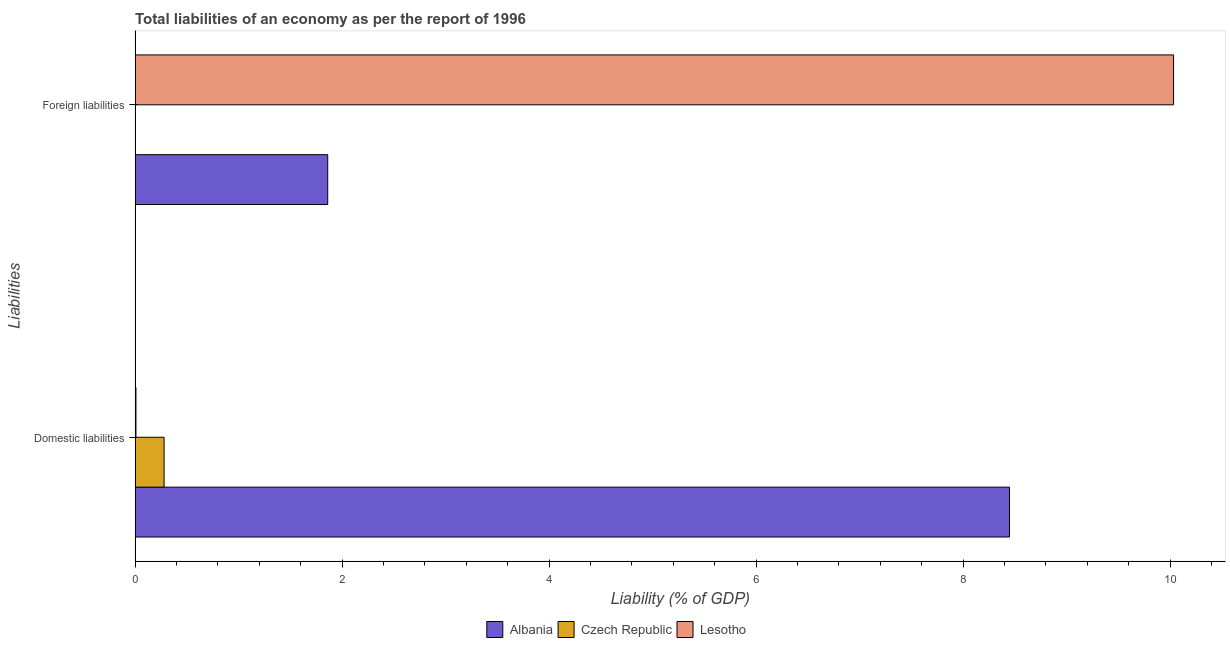How many different coloured bars are there?
Offer a terse response. 3. Are the number of bars on each tick of the Y-axis equal?
Make the answer very short. No. What is the label of the 1st group of bars from the top?
Provide a short and direct response. Foreign liabilities. What is the incurrence of domestic liabilities in Albania?
Your answer should be compact. 8.45. Across all countries, what is the maximum incurrence of domestic liabilities?
Your answer should be compact. 8.45. Across all countries, what is the minimum incurrence of domestic liabilities?
Offer a terse response. 0.01. In which country was the incurrence of domestic liabilities maximum?
Your response must be concise. Albania. What is the total incurrence of foreign liabilities in the graph?
Your answer should be compact. 11.9. What is the difference between the incurrence of domestic liabilities in Albania and that in Czech Republic?
Make the answer very short. 8.17. What is the difference between the incurrence of foreign liabilities in Czech Republic and the incurrence of domestic liabilities in Albania?
Give a very brief answer. -8.45. What is the average incurrence of foreign liabilities per country?
Provide a short and direct response. 3.97. What is the difference between the incurrence of domestic liabilities and incurrence of foreign liabilities in Lesotho?
Offer a very short reply. -10.03. What is the ratio of the incurrence of foreign liabilities in Lesotho to that in Albania?
Give a very brief answer. 5.39. Is the incurrence of domestic liabilities in Albania less than that in Czech Republic?
Give a very brief answer. No. How many countries are there in the graph?
Your answer should be very brief. 3. What is the difference between two consecutive major ticks on the X-axis?
Provide a succinct answer. 2. Does the graph contain any zero values?
Keep it short and to the point. Yes. How many legend labels are there?
Provide a succinct answer. 3. How are the legend labels stacked?
Offer a terse response. Horizontal. What is the title of the graph?
Your response must be concise. Total liabilities of an economy as per the report of 1996. Does "Serbia" appear as one of the legend labels in the graph?
Keep it short and to the point. No. What is the label or title of the X-axis?
Provide a succinct answer. Liability (% of GDP). What is the label or title of the Y-axis?
Ensure brevity in your answer.  Liabilities. What is the Liability (% of GDP) in Albania in Domestic liabilities?
Make the answer very short. 8.45. What is the Liability (% of GDP) of Czech Republic in Domestic liabilities?
Give a very brief answer. 0.28. What is the Liability (% of GDP) in Lesotho in Domestic liabilities?
Provide a succinct answer. 0.01. What is the Liability (% of GDP) in Albania in Foreign liabilities?
Make the answer very short. 1.86. What is the Liability (% of GDP) in Czech Republic in Foreign liabilities?
Make the answer very short. 0. What is the Liability (% of GDP) of Lesotho in Foreign liabilities?
Provide a short and direct response. 10.03. Across all Liabilities, what is the maximum Liability (% of GDP) of Albania?
Offer a terse response. 8.45. Across all Liabilities, what is the maximum Liability (% of GDP) in Czech Republic?
Keep it short and to the point. 0.28. Across all Liabilities, what is the maximum Liability (% of GDP) in Lesotho?
Offer a terse response. 10.03. Across all Liabilities, what is the minimum Liability (% of GDP) of Albania?
Keep it short and to the point. 1.86. Across all Liabilities, what is the minimum Liability (% of GDP) of Lesotho?
Keep it short and to the point. 0.01. What is the total Liability (% of GDP) of Albania in the graph?
Provide a succinct answer. 10.31. What is the total Liability (% of GDP) of Czech Republic in the graph?
Provide a short and direct response. 0.28. What is the total Liability (% of GDP) in Lesotho in the graph?
Ensure brevity in your answer.  10.04. What is the difference between the Liability (% of GDP) of Albania in Domestic liabilities and that in Foreign liabilities?
Offer a very short reply. 6.59. What is the difference between the Liability (% of GDP) in Lesotho in Domestic liabilities and that in Foreign liabilities?
Keep it short and to the point. -10.03. What is the difference between the Liability (% of GDP) in Albania in Domestic liabilities and the Liability (% of GDP) in Lesotho in Foreign liabilities?
Your response must be concise. -1.59. What is the difference between the Liability (% of GDP) in Czech Republic in Domestic liabilities and the Liability (% of GDP) in Lesotho in Foreign liabilities?
Your answer should be very brief. -9.75. What is the average Liability (% of GDP) in Albania per Liabilities?
Make the answer very short. 5.16. What is the average Liability (% of GDP) in Czech Republic per Liabilities?
Ensure brevity in your answer.  0.14. What is the average Liability (% of GDP) of Lesotho per Liabilities?
Give a very brief answer. 5.02. What is the difference between the Liability (% of GDP) of Albania and Liability (% of GDP) of Czech Republic in Domestic liabilities?
Your answer should be very brief. 8.17. What is the difference between the Liability (% of GDP) in Albania and Liability (% of GDP) in Lesotho in Domestic liabilities?
Your answer should be very brief. 8.44. What is the difference between the Liability (% of GDP) of Czech Republic and Liability (% of GDP) of Lesotho in Domestic liabilities?
Offer a terse response. 0.27. What is the difference between the Liability (% of GDP) of Albania and Liability (% of GDP) of Lesotho in Foreign liabilities?
Provide a succinct answer. -8.17. What is the ratio of the Liability (% of GDP) in Albania in Domestic liabilities to that in Foreign liabilities?
Provide a succinct answer. 4.54. What is the ratio of the Liability (% of GDP) in Lesotho in Domestic liabilities to that in Foreign liabilities?
Give a very brief answer. 0. What is the difference between the highest and the second highest Liability (% of GDP) in Albania?
Ensure brevity in your answer.  6.59. What is the difference between the highest and the second highest Liability (% of GDP) of Lesotho?
Offer a very short reply. 10.03. What is the difference between the highest and the lowest Liability (% of GDP) in Albania?
Provide a short and direct response. 6.59. What is the difference between the highest and the lowest Liability (% of GDP) in Czech Republic?
Offer a very short reply. 0.28. What is the difference between the highest and the lowest Liability (% of GDP) of Lesotho?
Offer a very short reply. 10.03. 